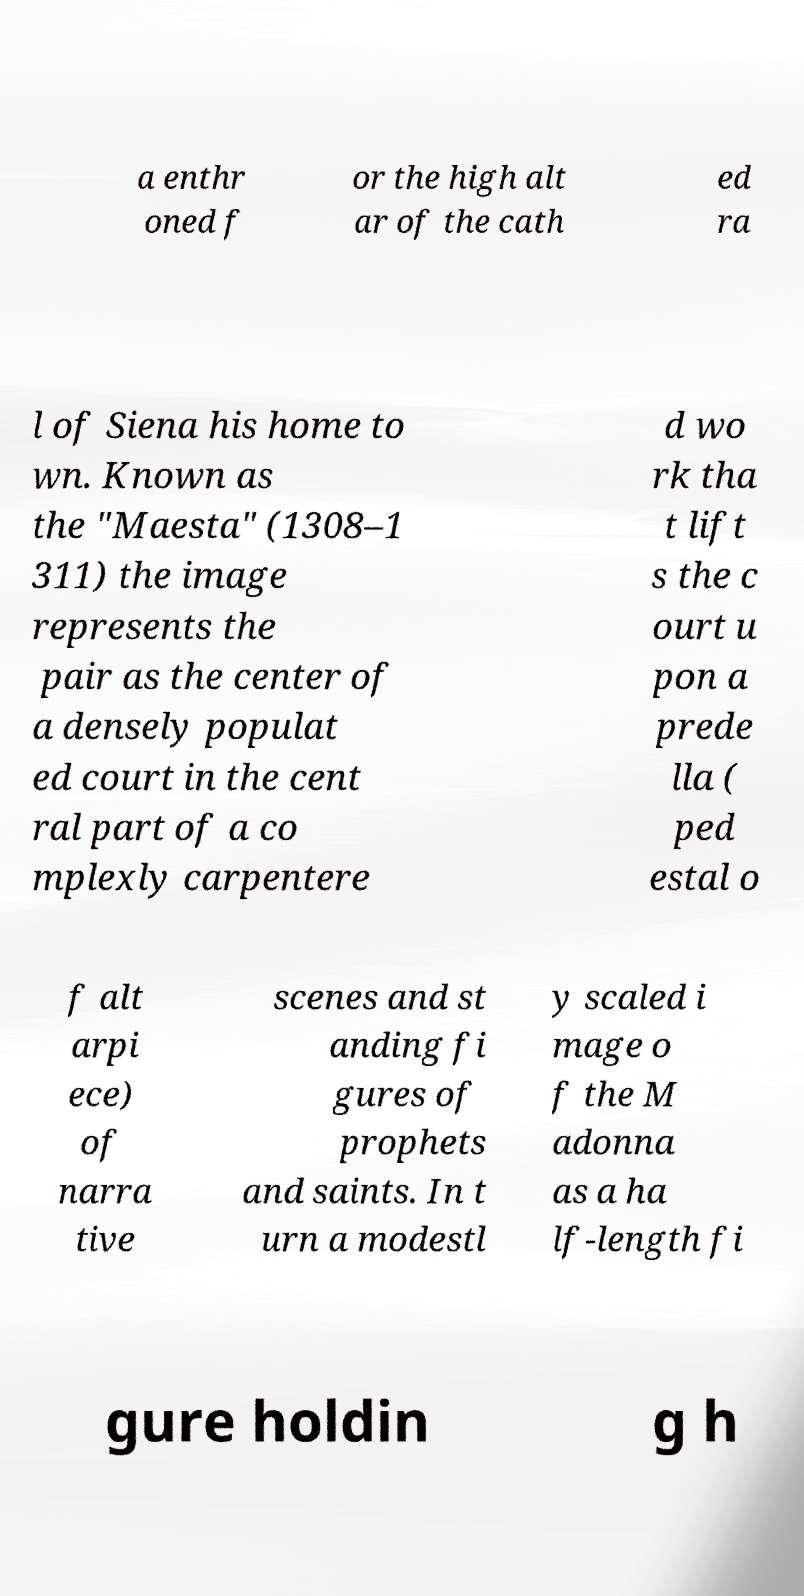Please read and relay the text visible in this image. What does it say? a enthr oned f or the high alt ar of the cath ed ra l of Siena his home to wn. Known as the "Maesta" (1308–1 311) the image represents the pair as the center of a densely populat ed court in the cent ral part of a co mplexly carpentere d wo rk tha t lift s the c ourt u pon a prede lla ( ped estal o f alt arpi ece) of narra tive scenes and st anding fi gures of prophets and saints. In t urn a modestl y scaled i mage o f the M adonna as a ha lf-length fi gure holdin g h 